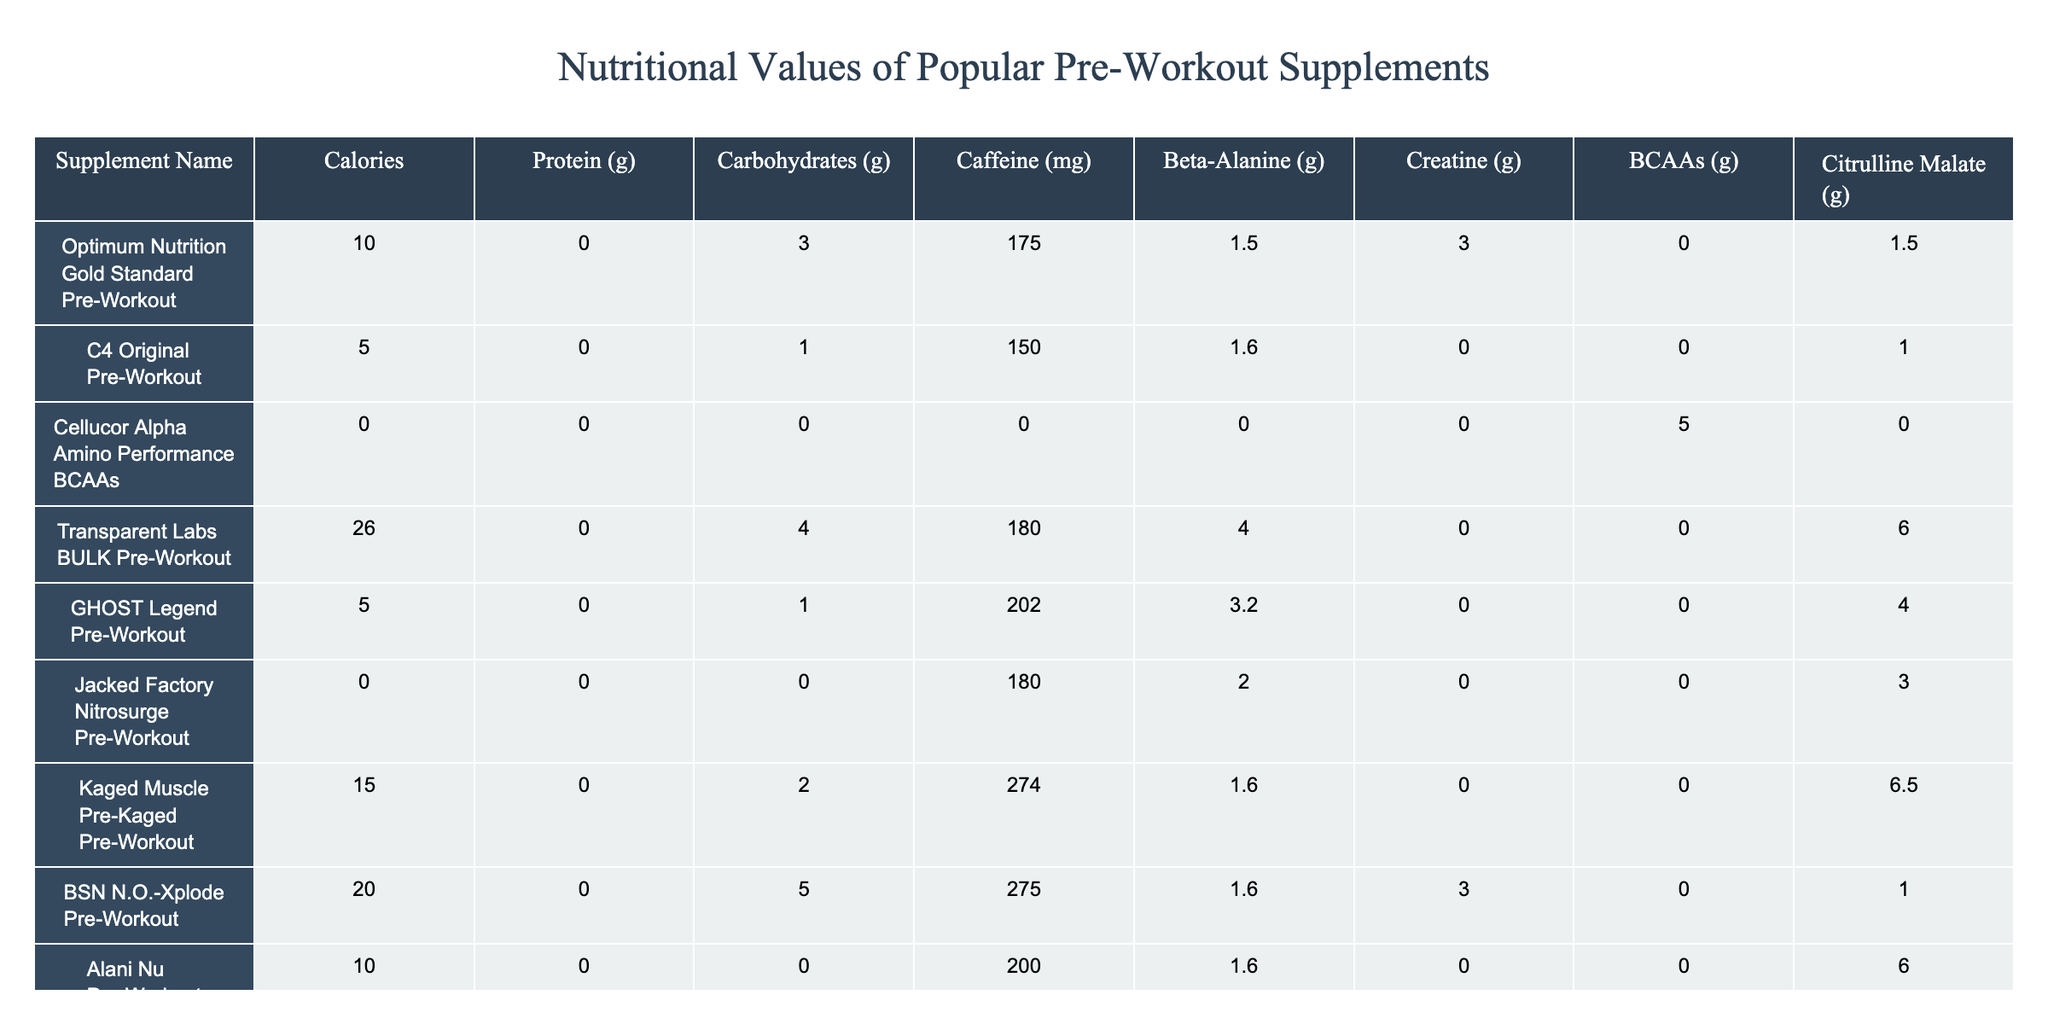What is the caffeine content of the GHOST Legend Pre-Workout? The table lists GHOST Legend Pre-Workout under the "Supplement Name" column, with a corresponding "Caffeine (mg)" value of 202.
Answer: 202 mg Which supplement has the highest protein content? Looking through the table, the only supplement with protein content listed is Muscle Pharm Assault Pre-Workout with 1 g of protein. The rest have a value of 0.
Answer: Muscle Pharm Assault Pre-Workout What is the total number of carbohydrates in all supplements combined? Summing the carbohydrate values of each supplement gives: 3 + 1 + 0 + 4 + 1 + 0 + 2 + 5 + 0 + 1 = 17 g.
Answer: 17 g Does the Cellucor Alpha Amino Performance BCAAs supplement contain any carbohydrates? According to the table, Cellucor Alpha Amino Performance BCAAs has 0 g of carbohydrates listed in the "Carbohydrates (g)" column.
Answer: No Which supplement has the least calories, and what is that value? The minimum value for calories among the listed supplements is 0, which is seen in both Jacked Factory Nitrosurge Pre-Workout and Cellucor Alpha Amino Performance BCAAs.
Answer: 0 calories What is the average caffeine content across all listed supplements? The caffeine contents are: 175, 150, 0, 180, 202, 180, 274, 275, 200, 200. Adding these values gives 1741 mg. Dividing this by 10 (the total number of supplements) gives an average of 174.1 mg.
Answer: 174.1 mg Does any supplement contain both beta-alanine and creatine? The only supplement that has both beta-alanine (4 g) and creatine (0 g) is Transparent Labs BULK Pre-Workout, indicating that it contains beta-alanine.
Answer: Yes Which supplement contains the highest amount of Citrulline Malate? Comparing the values under the "Citrulline Malate (g)" column, the Kaged Muscle Pre-Kaged Pre-Workout has the highest value at 6.5 g.
Answer: Kaged Muscle Pre-Kaged Pre-Workout If a person wants to avoid caffeine completely, which supplements would be suitable? The only absolute caffeine-free supplements in the table are Cellucor Alpha Amino Performance BCAAs and Jacked Factory Nitrosurge Pre-Workout, both with 0 mg of caffeine.
Answer: Cellucor Alpha Amino Performance BCAAs and Jacked Factory Nitrosurge Pre-Workout What is the combined total of BCAAs for all supplements that contain them? The supplements containing BCAAs are: Cellucor Alpha Amino Performance BCAAs (5 g), and Muscle Pharm Assault Pre-Workout (0 g). Adding these values together gives 5 g.
Answer: 5 g 